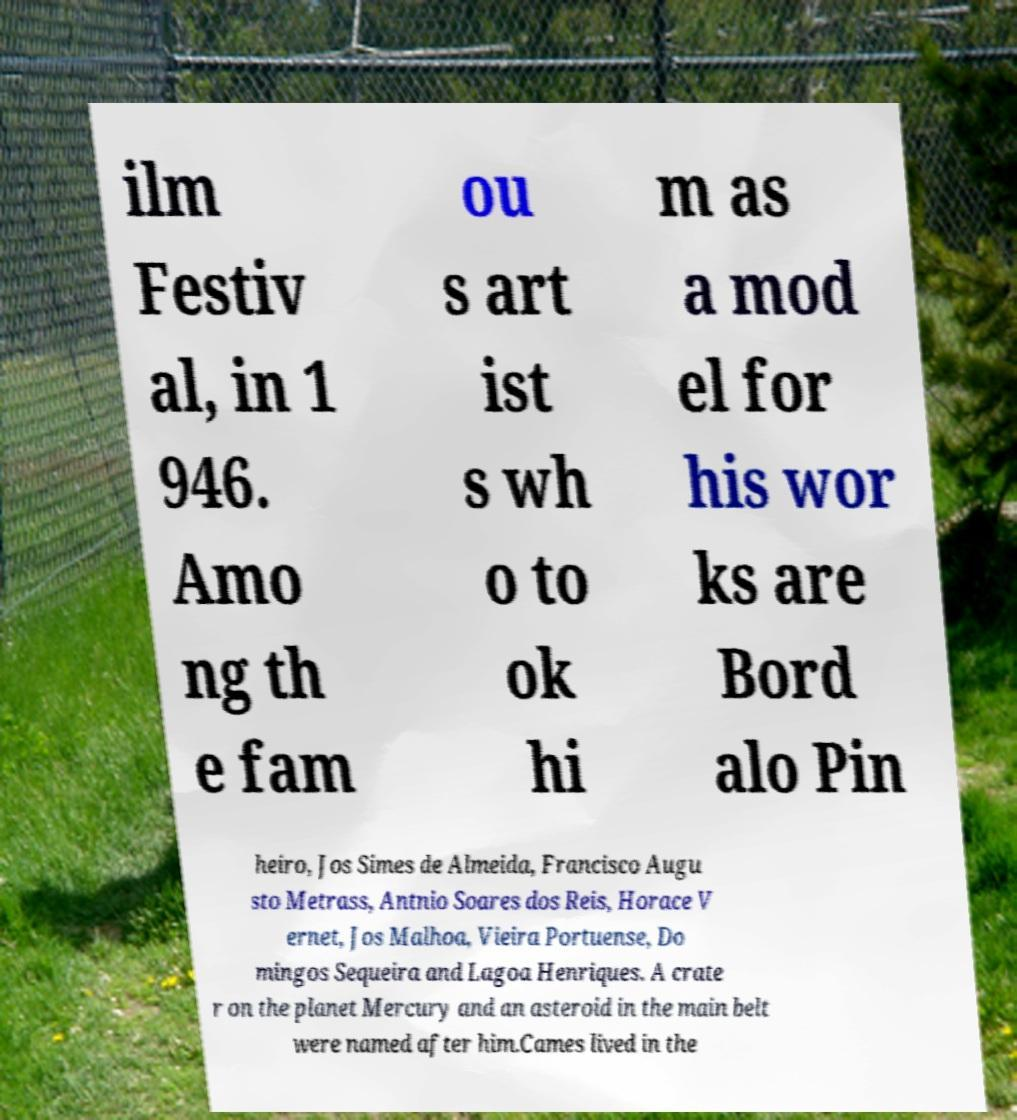There's text embedded in this image that I need extracted. Can you transcribe it verbatim? ilm Festiv al, in 1 946. Amo ng th e fam ou s art ist s wh o to ok hi m as a mod el for his wor ks are Bord alo Pin heiro, Jos Simes de Almeida, Francisco Augu sto Metrass, Antnio Soares dos Reis, Horace V ernet, Jos Malhoa, Vieira Portuense, Do mingos Sequeira and Lagoa Henriques. A crate r on the planet Mercury and an asteroid in the main belt were named after him.Cames lived in the 